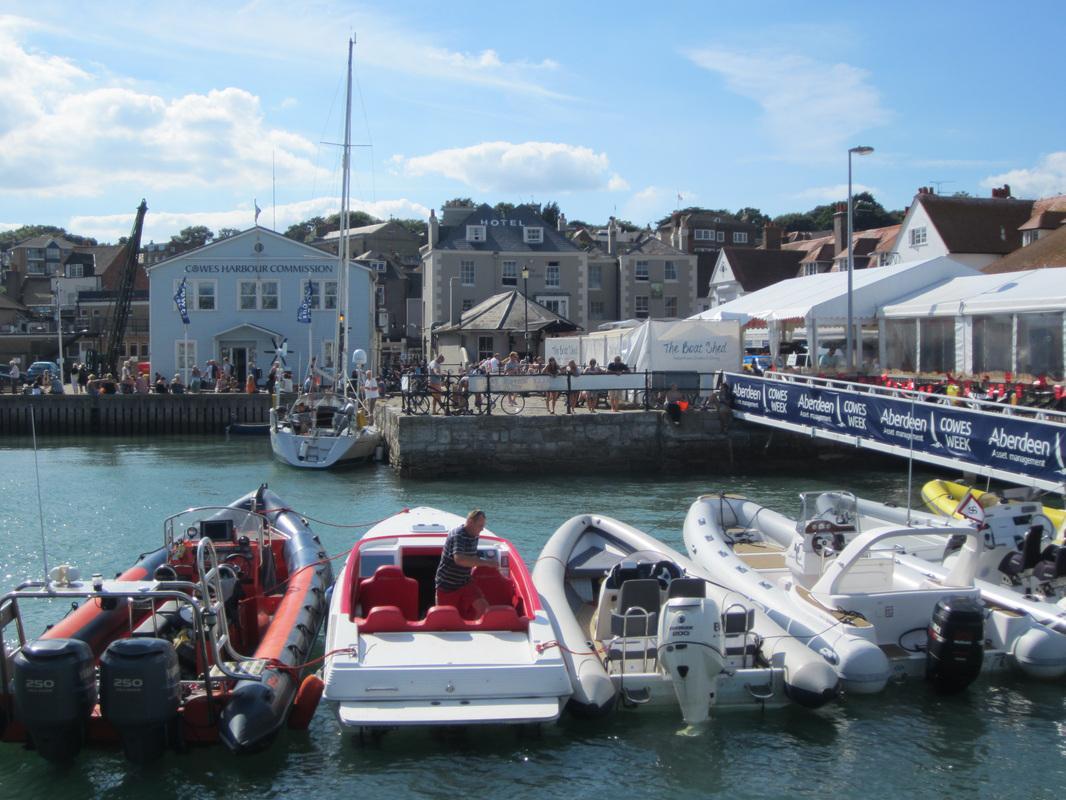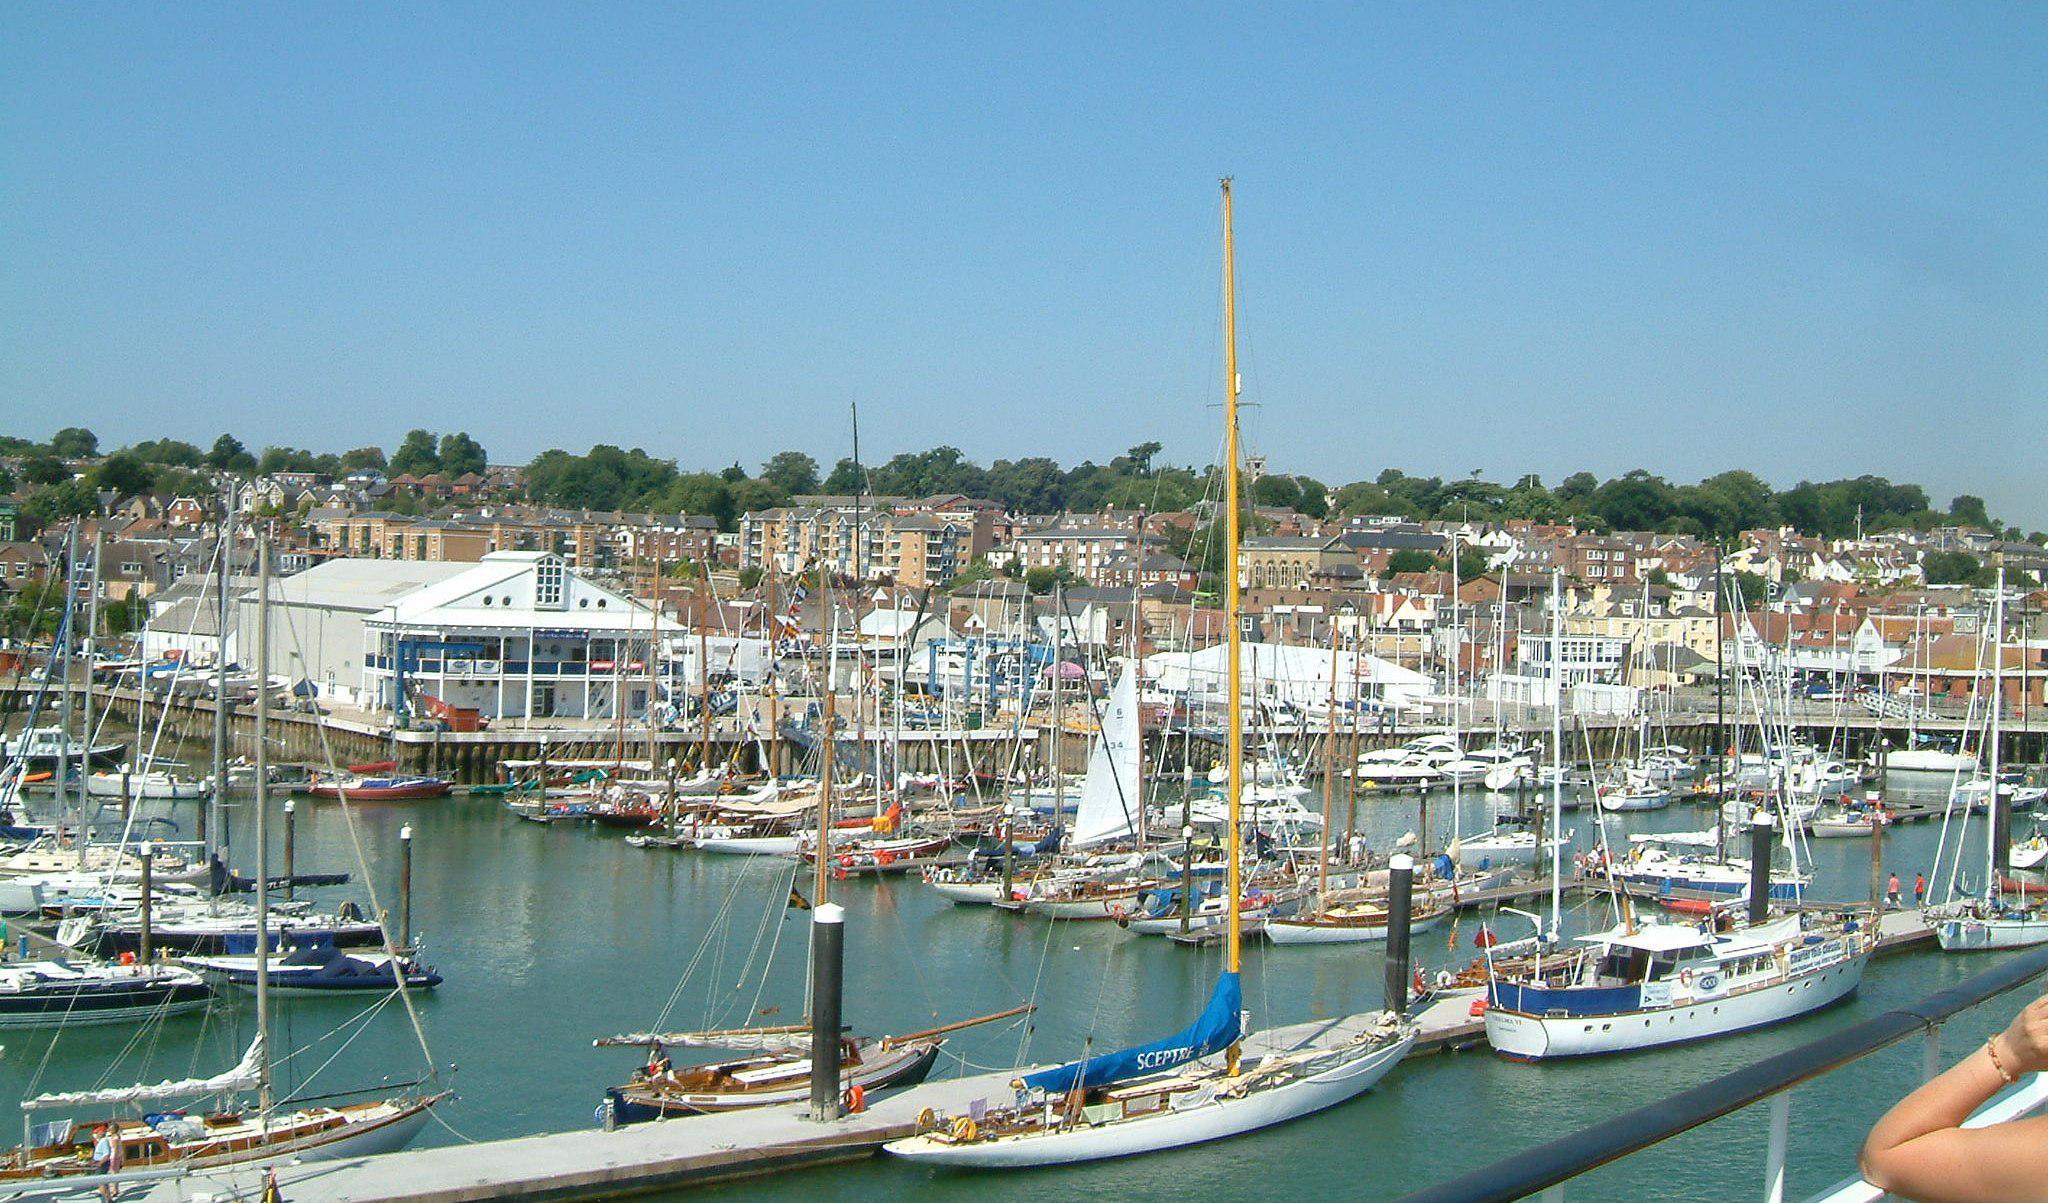The first image is the image on the left, the second image is the image on the right. Considering the images on both sides, is "Boats float in the water on a sunny day in the image on the right." valid? Answer yes or no. Yes. The first image is the image on the left, the second image is the image on the right. Given the left and right images, does the statement "At least one image shows a harbor and an expanse of water leading into a narrower canal lined with houses and other buildings." hold true? Answer yes or no. Yes. 